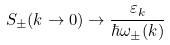Convert formula to latex. <formula><loc_0><loc_0><loc_500><loc_500>S _ { \pm } ( k \rightarrow 0 ) \rightarrow \frac { \varepsilon _ { k } } { \hbar { \omega } _ { \pm } ( k ) }</formula> 